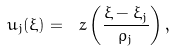<formula> <loc_0><loc_0><loc_500><loc_500>u _ { j } ( \xi ) = \ z \left ( \frac { \xi - \xi _ { j } } { \rho _ { j } } \right ) ,</formula> 